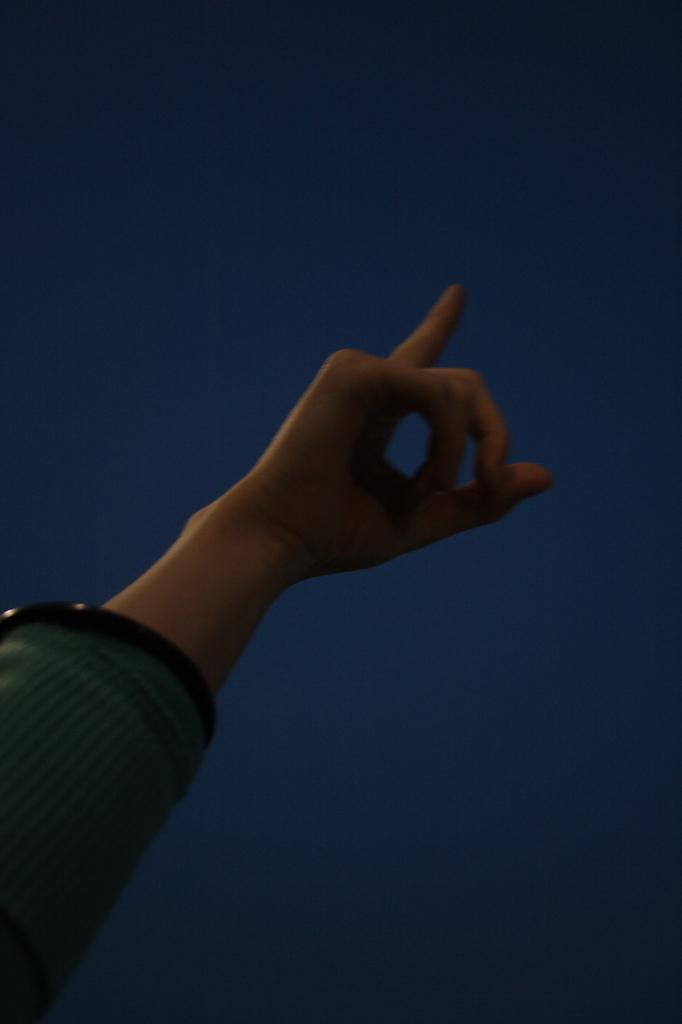In one or two sentences, can you explain what this image depicts? In this image we can see the hand of a person, and the background is blue in color. 